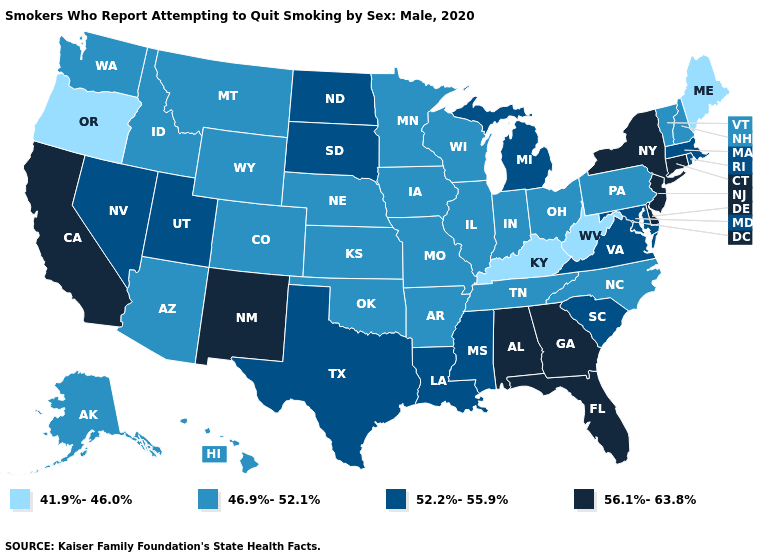What is the lowest value in states that border Kansas?
Quick response, please. 46.9%-52.1%. Does Washington have a higher value than Rhode Island?
Give a very brief answer. No. Does the first symbol in the legend represent the smallest category?
Short answer required. Yes. Name the states that have a value in the range 46.9%-52.1%?
Be succinct. Alaska, Arizona, Arkansas, Colorado, Hawaii, Idaho, Illinois, Indiana, Iowa, Kansas, Minnesota, Missouri, Montana, Nebraska, New Hampshire, North Carolina, Ohio, Oklahoma, Pennsylvania, Tennessee, Vermont, Washington, Wisconsin, Wyoming. Among the states that border Illinois , does Missouri have the lowest value?
Concise answer only. No. Name the states that have a value in the range 46.9%-52.1%?
Keep it brief. Alaska, Arizona, Arkansas, Colorado, Hawaii, Idaho, Illinois, Indiana, Iowa, Kansas, Minnesota, Missouri, Montana, Nebraska, New Hampshire, North Carolina, Ohio, Oklahoma, Pennsylvania, Tennessee, Vermont, Washington, Wisconsin, Wyoming. What is the value of Indiana?
Short answer required. 46.9%-52.1%. Among the states that border Delaware , does New Jersey have the highest value?
Quick response, please. Yes. Among the states that border Vermont , which have the lowest value?
Concise answer only. New Hampshire. Does Vermont have the same value as Virginia?
Write a very short answer. No. What is the highest value in the USA?
Short answer required. 56.1%-63.8%. Name the states that have a value in the range 41.9%-46.0%?
Concise answer only. Kentucky, Maine, Oregon, West Virginia. Name the states that have a value in the range 56.1%-63.8%?
Quick response, please. Alabama, California, Connecticut, Delaware, Florida, Georgia, New Jersey, New Mexico, New York. What is the value of Kansas?
Answer briefly. 46.9%-52.1%. Does Florida have the highest value in the USA?
Be succinct. Yes. 